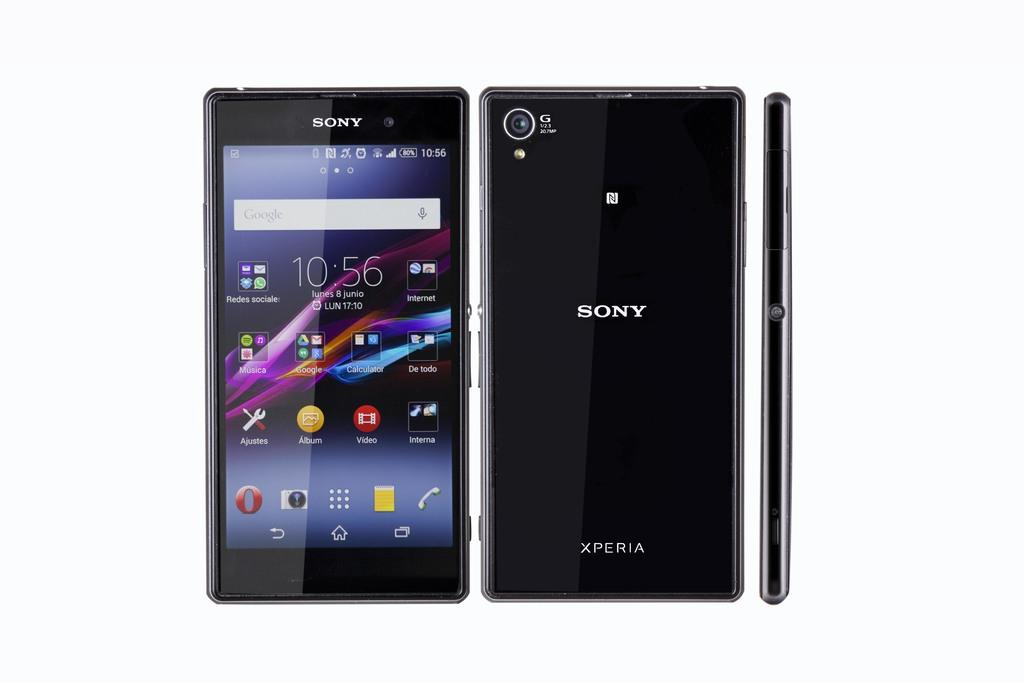<image>
Write a terse but informative summary of the picture. a phone that has the word Sony on it 